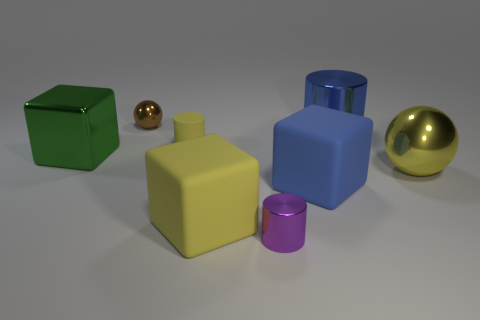Add 1 large rubber things. How many objects exist? 9 Subtract all cubes. How many objects are left? 5 Add 4 metal spheres. How many metal spheres are left? 6 Add 2 yellow rubber cylinders. How many yellow rubber cylinders exist? 3 Subtract 1 blue cylinders. How many objects are left? 7 Subtract all big gray blocks. Subtract all matte cylinders. How many objects are left? 7 